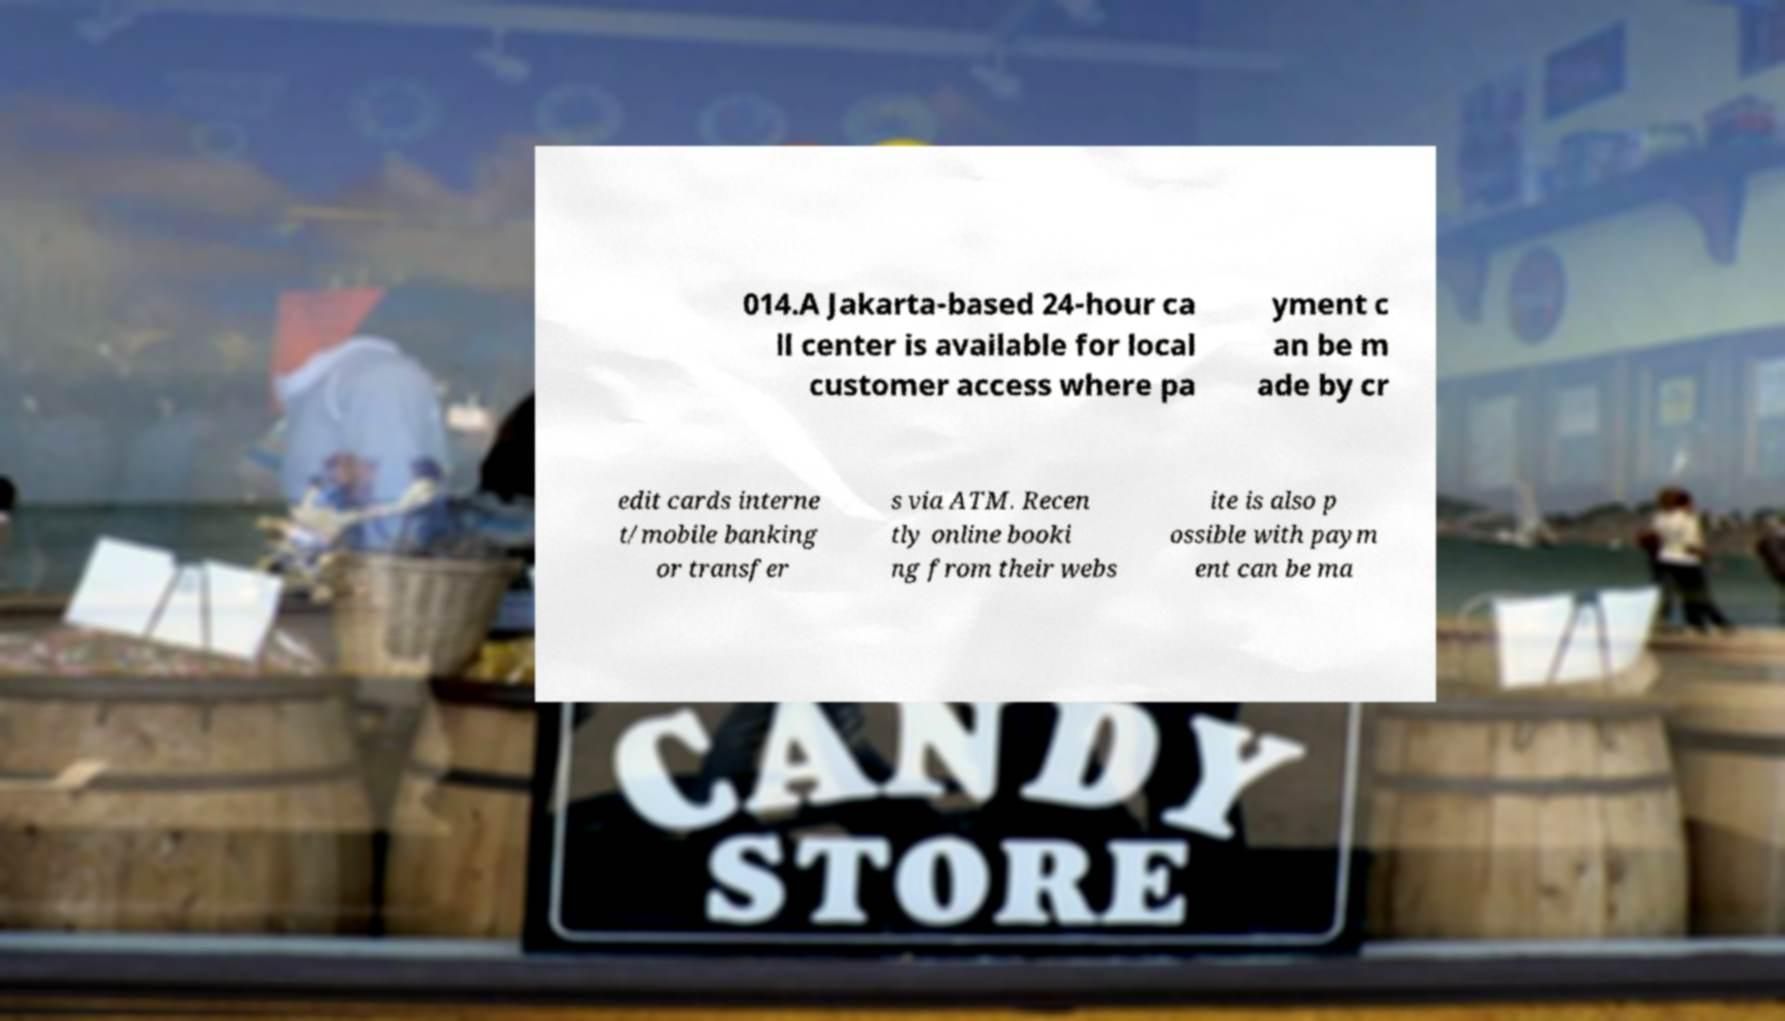Can you read and provide the text displayed in the image?This photo seems to have some interesting text. Can you extract and type it out for me? 014.A Jakarta-based 24-hour ca ll center is available for local customer access where pa yment c an be m ade by cr edit cards interne t/mobile banking or transfer s via ATM. Recen tly online booki ng from their webs ite is also p ossible with paym ent can be ma 